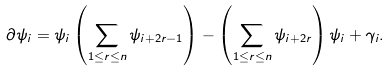Convert formula to latex. <formula><loc_0><loc_0><loc_500><loc_500>& \partial \psi _ { i } = \psi _ { i } \left ( \sum _ { 1 \leq r \leq n } \psi _ { i + 2 r - 1 } \right ) - \left ( \sum _ { 1 \leq r \leq n } \psi _ { i + 2 r } \right ) \psi _ { i } + \gamma _ { i } .</formula> 